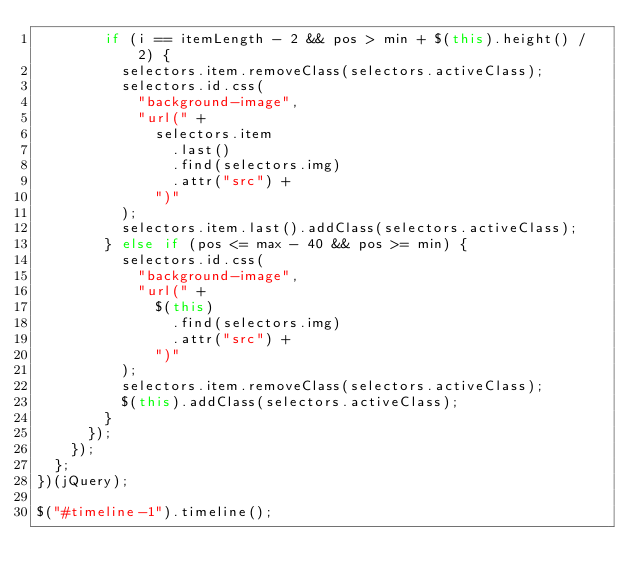<code> <loc_0><loc_0><loc_500><loc_500><_JavaScript_>        if (i == itemLength - 2 && pos > min + $(this).height() / 2) {
          selectors.item.removeClass(selectors.activeClass);
          selectors.id.css(
            "background-image",
            "url(" +
              selectors.item
                .last()
                .find(selectors.img)
                .attr("src") +
              ")"
          );
          selectors.item.last().addClass(selectors.activeClass);
        } else if (pos <= max - 40 && pos >= min) {
          selectors.id.css(
            "background-image",
            "url(" +
              $(this)
                .find(selectors.img)
                .attr("src") +
              ")"
          );
          selectors.item.removeClass(selectors.activeClass);
          $(this).addClass(selectors.activeClass);
        }
      });
    });
  };
})(jQuery);

$("#timeline-1").timeline();</code> 